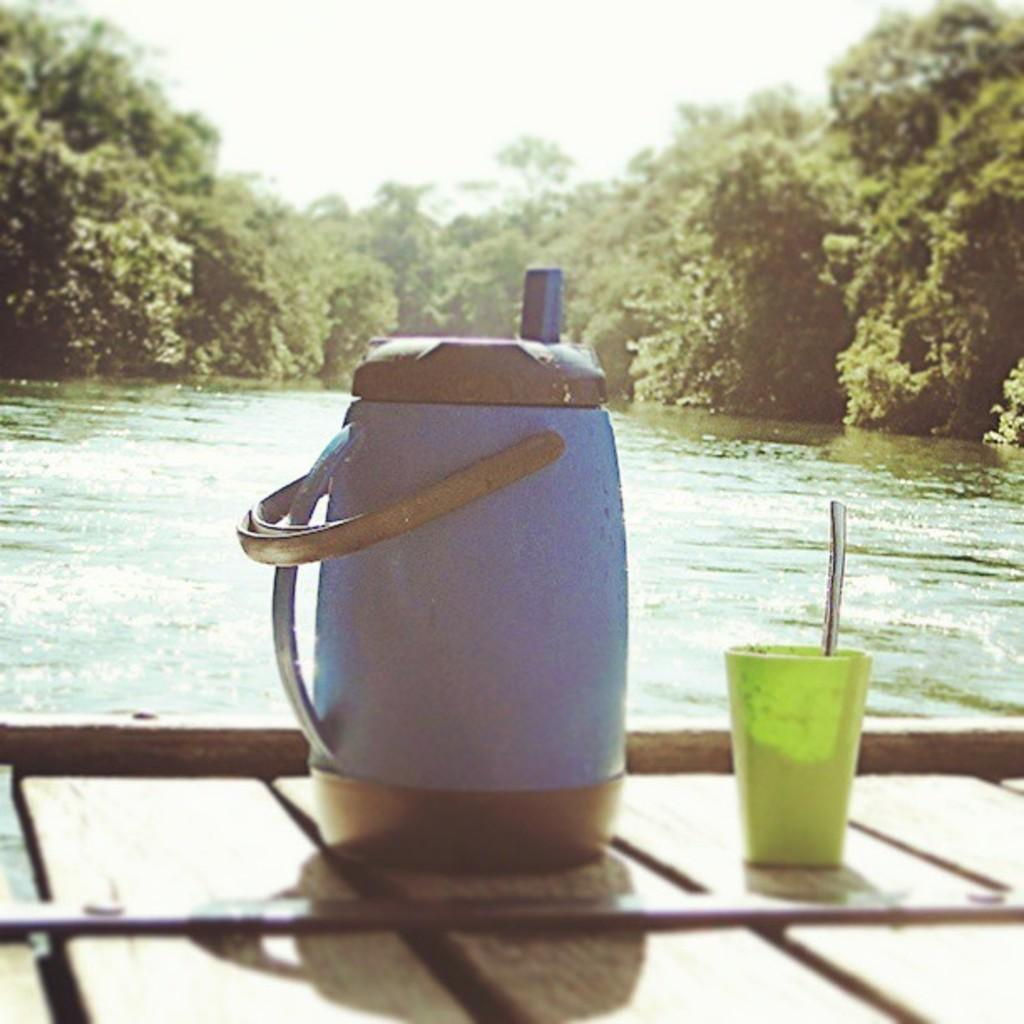What is the main object in the image? There is a flask in the image. What other object is related to the flask? There is a spoon in a cup in the image. Where are the flask and the cup placed? Both the flask and the cup are placed on a table. What can be seen in the background of the image? There are trees and water visible in the background of the image. What verse is being recited by the celery in the image? There is no celery present in the image, and therefore no verse being recited. 